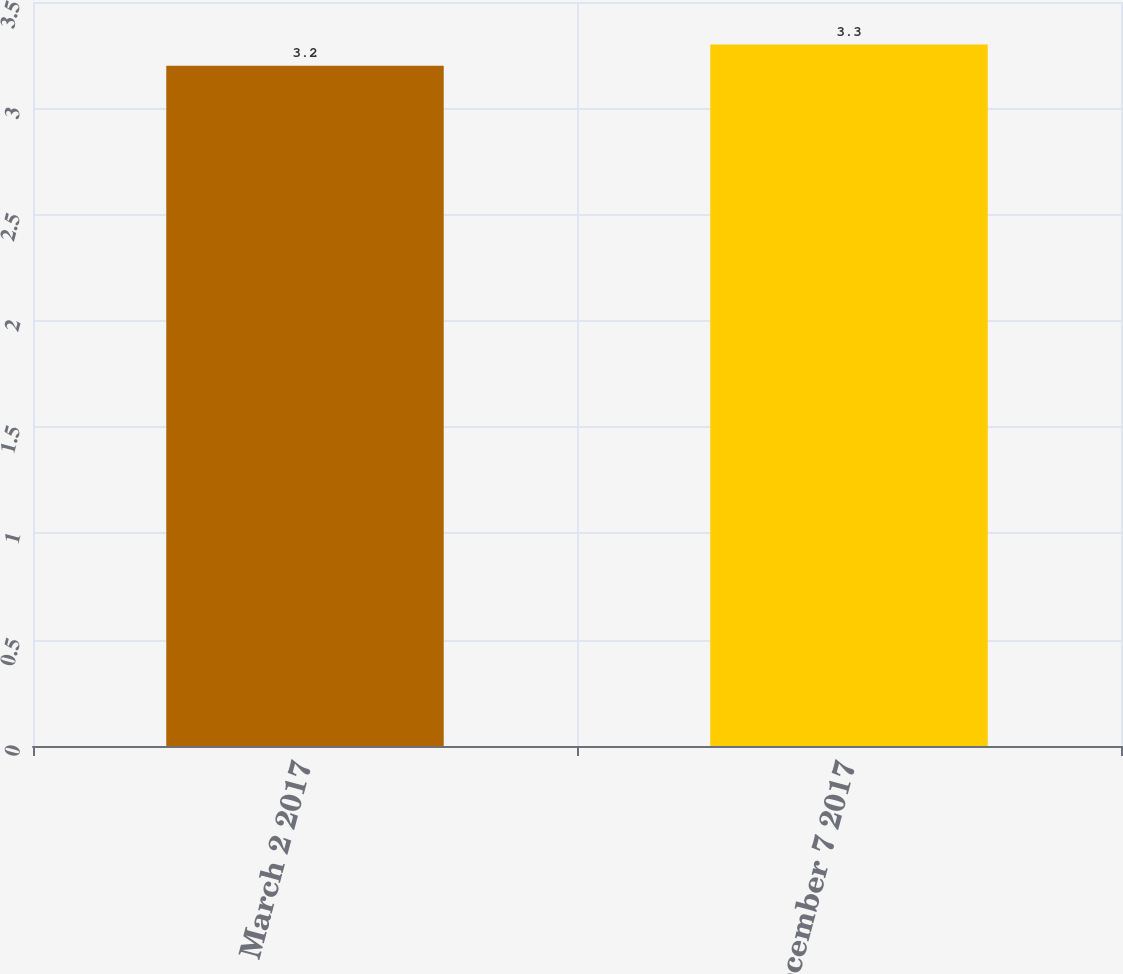Convert chart. <chart><loc_0><loc_0><loc_500><loc_500><bar_chart><fcel>March 2 2017<fcel>December 7 2017<nl><fcel>3.2<fcel>3.3<nl></chart> 